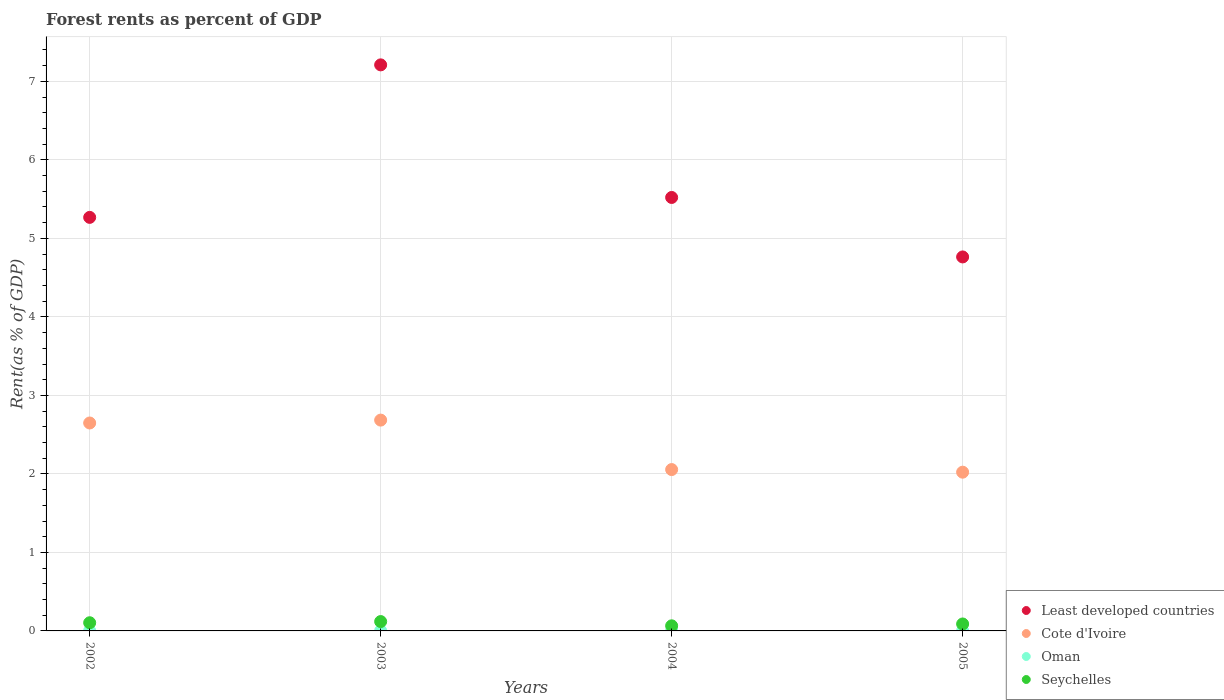What is the forest rent in Oman in 2002?
Make the answer very short. 0. Across all years, what is the maximum forest rent in Least developed countries?
Offer a very short reply. 7.21. Across all years, what is the minimum forest rent in Cote d'Ivoire?
Offer a terse response. 2.02. In which year was the forest rent in Oman maximum?
Ensure brevity in your answer.  2004. What is the total forest rent in Least developed countries in the graph?
Keep it short and to the point. 22.76. What is the difference between the forest rent in Seychelles in 2002 and that in 2003?
Provide a short and direct response. -0.02. What is the difference between the forest rent in Least developed countries in 2002 and the forest rent in Seychelles in 2005?
Keep it short and to the point. 5.18. What is the average forest rent in Least developed countries per year?
Provide a short and direct response. 5.69. In the year 2004, what is the difference between the forest rent in Seychelles and forest rent in Oman?
Your answer should be very brief. 0.06. In how many years, is the forest rent in Seychelles greater than 1.2 %?
Your answer should be compact. 0. What is the ratio of the forest rent in Oman in 2002 to that in 2004?
Provide a succinct answer. 0.96. Is the forest rent in Oman in 2003 less than that in 2005?
Make the answer very short. No. Is the difference between the forest rent in Seychelles in 2003 and 2004 greater than the difference between the forest rent in Oman in 2003 and 2004?
Give a very brief answer. Yes. What is the difference between the highest and the second highest forest rent in Cote d'Ivoire?
Your answer should be compact. 0.04. What is the difference between the highest and the lowest forest rent in Least developed countries?
Provide a short and direct response. 2.45. In how many years, is the forest rent in Oman greater than the average forest rent in Oman taken over all years?
Keep it short and to the point. 3. Is the sum of the forest rent in Oman in 2002 and 2005 greater than the maximum forest rent in Least developed countries across all years?
Your answer should be very brief. No. Does the forest rent in Least developed countries monotonically increase over the years?
Provide a short and direct response. No. Is the forest rent in Least developed countries strictly greater than the forest rent in Cote d'Ivoire over the years?
Your response must be concise. Yes. How many dotlines are there?
Provide a short and direct response. 4. What is the difference between two consecutive major ticks on the Y-axis?
Offer a terse response. 1. Does the graph contain grids?
Offer a very short reply. Yes. Where does the legend appear in the graph?
Offer a terse response. Bottom right. How many legend labels are there?
Your answer should be very brief. 4. How are the legend labels stacked?
Provide a short and direct response. Vertical. What is the title of the graph?
Provide a short and direct response. Forest rents as percent of GDP. What is the label or title of the Y-axis?
Your answer should be very brief. Rent(as % of GDP). What is the Rent(as % of GDP) of Least developed countries in 2002?
Your answer should be compact. 5.27. What is the Rent(as % of GDP) of Cote d'Ivoire in 2002?
Your answer should be compact. 2.65. What is the Rent(as % of GDP) in Oman in 2002?
Provide a short and direct response. 0. What is the Rent(as % of GDP) of Seychelles in 2002?
Ensure brevity in your answer.  0.1. What is the Rent(as % of GDP) in Least developed countries in 2003?
Give a very brief answer. 7.21. What is the Rent(as % of GDP) of Cote d'Ivoire in 2003?
Offer a very short reply. 2.69. What is the Rent(as % of GDP) of Oman in 2003?
Keep it short and to the point. 0. What is the Rent(as % of GDP) in Seychelles in 2003?
Ensure brevity in your answer.  0.12. What is the Rent(as % of GDP) in Least developed countries in 2004?
Make the answer very short. 5.52. What is the Rent(as % of GDP) in Cote d'Ivoire in 2004?
Provide a short and direct response. 2.06. What is the Rent(as % of GDP) in Oman in 2004?
Make the answer very short. 0. What is the Rent(as % of GDP) in Seychelles in 2004?
Provide a short and direct response. 0.06. What is the Rent(as % of GDP) in Least developed countries in 2005?
Ensure brevity in your answer.  4.76. What is the Rent(as % of GDP) in Cote d'Ivoire in 2005?
Offer a very short reply. 2.02. What is the Rent(as % of GDP) in Oman in 2005?
Make the answer very short. 0. What is the Rent(as % of GDP) in Seychelles in 2005?
Offer a terse response. 0.09. Across all years, what is the maximum Rent(as % of GDP) of Least developed countries?
Your response must be concise. 7.21. Across all years, what is the maximum Rent(as % of GDP) of Cote d'Ivoire?
Provide a succinct answer. 2.69. Across all years, what is the maximum Rent(as % of GDP) in Oman?
Your response must be concise. 0. Across all years, what is the maximum Rent(as % of GDP) in Seychelles?
Your answer should be compact. 0.12. Across all years, what is the minimum Rent(as % of GDP) of Least developed countries?
Offer a terse response. 4.76. Across all years, what is the minimum Rent(as % of GDP) in Cote d'Ivoire?
Offer a very short reply. 2.02. Across all years, what is the minimum Rent(as % of GDP) of Oman?
Your response must be concise. 0. Across all years, what is the minimum Rent(as % of GDP) in Seychelles?
Give a very brief answer. 0.06. What is the total Rent(as % of GDP) of Least developed countries in the graph?
Give a very brief answer. 22.76. What is the total Rent(as % of GDP) in Cote d'Ivoire in the graph?
Your response must be concise. 9.41. What is the total Rent(as % of GDP) in Oman in the graph?
Your response must be concise. 0.01. What is the total Rent(as % of GDP) of Seychelles in the graph?
Provide a short and direct response. 0.38. What is the difference between the Rent(as % of GDP) of Least developed countries in 2002 and that in 2003?
Make the answer very short. -1.94. What is the difference between the Rent(as % of GDP) of Cote d'Ivoire in 2002 and that in 2003?
Your answer should be very brief. -0.04. What is the difference between the Rent(as % of GDP) of Oman in 2002 and that in 2003?
Give a very brief answer. -0. What is the difference between the Rent(as % of GDP) in Seychelles in 2002 and that in 2003?
Make the answer very short. -0.02. What is the difference between the Rent(as % of GDP) in Least developed countries in 2002 and that in 2004?
Offer a terse response. -0.25. What is the difference between the Rent(as % of GDP) of Cote d'Ivoire in 2002 and that in 2004?
Your answer should be compact. 0.59. What is the difference between the Rent(as % of GDP) of Oman in 2002 and that in 2004?
Offer a terse response. -0. What is the difference between the Rent(as % of GDP) of Seychelles in 2002 and that in 2004?
Keep it short and to the point. 0.04. What is the difference between the Rent(as % of GDP) of Least developed countries in 2002 and that in 2005?
Give a very brief answer. 0.5. What is the difference between the Rent(as % of GDP) of Cote d'Ivoire in 2002 and that in 2005?
Ensure brevity in your answer.  0.63. What is the difference between the Rent(as % of GDP) in Oman in 2002 and that in 2005?
Your answer should be compact. 0. What is the difference between the Rent(as % of GDP) in Seychelles in 2002 and that in 2005?
Ensure brevity in your answer.  0.02. What is the difference between the Rent(as % of GDP) of Least developed countries in 2003 and that in 2004?
Keep it short and to the point. 1.69. What is the difference between the Rent(as % of GDP) of Cote d'Ivoire in 2003 and that in 2004?
Offer a very short reply. 0.63. What is the difference between the Rent(as % of GDP) of Seychelles in 2003 and that in 2004?
Offer a terse response. 0.05. What is the difference between the Rent(as % of GDP) of Least developed countries in 2003 and that in 2005?
Provide a succinct answer. 2.45. What is the difference between the Rent(as % of GDP) of Cote d'Ivoire in 2003 and that in 2005?
Provide a succinct answer. 0.66. What is the difference between the Rent(as % of GDP) of Oman in 2003 and that in 2005?
Make the answer very short. 0. What is the difference between the Rent(as % of GDP) in Seychelles in 2003 and that in 2005?
Offer a terse response. 0.03. What is the difference between the Rent(as % of GDP) of Least developed countries in 2004 and that in 2005?
Your response must be concise. 0.76. What is the difference between the Rent(as % of GDP) in Oman in 2004 and that in 2005?
Your response must be concise. 0. What is the difference between the Rent(as % of GDP) in Seychelles in 2004 and that in 2005?
Ensure brevity in your answer.  -0.02. What is the difference between the Rent(as % of GDP) in Least developed countries in 2002 and the Rent(as % of GDP) in Cote d'Ivoire in 2003?
Give a very brief answer. 2.58. What is the difference between the Rent(as % of GDP) of Least developed countries in 2002 and the Rent(as % of GDP) of Oman in 2003?
Your answer should be very brief. 5.26. What is the difference between the Rent(as % of GDP) of Least developed countries in 2002 and the Rent(as % of GDP) of Seychelles in 2003?
Provide a succinct answer. 5.15. What is the difference between the Rent(as % of GDP) of Cote d'Ivoire in 2002 and the Rent(as % of GDP) of Oman in 2003?
Ensure brevity in your answer.  2.65. What is the difference between the Rent(as % of GDP) of Cote d'Ivoire in 2002 and the Rent(as % of GDP) of Seychelles in 2003?
Provide a succinct answer. 2.53. What is the difference between the Rent(as % of GDP) in Oman in 2002 and the Rent(as % of GDP) in Seychelles in 2003?
Your response must be concise. -0.12. What is the difference between the Rent(as % of GDP) of Least developed countries in 2002 and the Rent(as % of GDP) of Cote d'Ivoire in 2004?
Ensure brevity in your answer.  3.21. What is the difference between the Rent(as % of GDP) in Least developed countries in 2002 and the Rent(as % of GDP) in Oman in 2004?
Offer a very short reply. 5.26. What is the difference between the Rent(as % of GDP) of Least developed countries in 2002 and the Rent(as % of GDP) of Seychelles in 2004?
Your response must be concise. 5.2. What is the difference between the Rent(as % of GDP) in Cote d'Ivoire in 2002 and the Rent(as % of GDP) in Oman in 2004?
Offer a terse response. 2.65. What is the difference between the Rent(as % of GDP) of Cote d'Ivoire in 2002 and the Rent(as % of GDP) of Seychelles in 2004?
Offer a very short reply. 2.58. What is the difference between the Rent(as % of GDP) of Oman in 2002 and the Rent(as % of GDP) of Seychelles in 2004?
Give a very brief answer. -0.06. What is the difference between the Rent(as % of GDP) in Least developed countries in 2002 and the Rent(as % of GDP) in Cote d'Ivoire in 2005?
Provide a succinct answer. 3.25. What is the difference between the Rent(as % of GDP) of Least developed countries in 2002 and the Rent(as % of GDP) of Oman in 2005?
Your response must be concise. 5.27. What is the difference between the Rent(as % of GDP) in Least developed countries in 2002 and the Rent(as % of GDP) in Seychelles in 2005?
Your answer should be compact. 5.18. What is the difference between the Rent(as % of GDP) of Cote d'Ivoire in 2002 and the Rent(as % of GDP) of Oman in 2005?
Your answer should be very brief. 2.65. What is the difference between the Rent(as % of GDP) in Cote d'Ivoire in 2002 and the Rent(as % of GDP) in Seychelles in 2005?
Keep it short and to the point. 2.56. What is the difference between the Rent(as % of GDP) of Oman in 2002 and the Rent(as % of GDP) of Seychelles in 2005?
Your response must be concise. -0.09. What is the difference between the Rent(as % of GDP) in Least developed countries in 2003 and the Rent(as % of GDP) in Cote d'Ivoire in 2004?
Make the answer very short. 5.16. What is the difference between the Rent(as % of GDP) in Least developed countries in 2003 and the Rent(as % of GDP) in Oman in 2004?
Make the answer very short. 7.21. What is the difference between the Rent(as % of GDP) in Least developed countries in 2003 and the Rent(as % of GDP) in Seychelles in 2004?
Keep it short and to the point. 7.15. What is the difference between the Rent(as % of GDP) of Cote d'Ivoire in 2003 and the Rent(as % of GDP) of Oman in 2004?
Ensure brevity in your answer.  2.68. What is the difference between the Rent(as % of GDP) in Cote d'Ivoire in 2003 and the Rent(as % of GDP) in Seychelles in 2004?
Your answer should be very brief. 2.62. What is the difference between the Rent(as % of GDP) of Oman in 2003 and the Rent(as % of GDP) of Seychelles in 2004?
Ensure brevity in your answer.  -0.06. What is the difference between the Rent(as % of GDP) of Least developed countries in 2003 and the Rent(as % of GDP) of Cote d'Ivoire in 2005?
Your answer should be very brief. 5.19. What is the difference between the Rent(as % of GDP) of Least developed countries in 2003 and the Rent(as % of GDP) of Oman in 2005?
Your response must be concise. 7.21. What is the difference between the Rent(as % of GDP) of Least developed countries in 2003 and the Rent(as % of GDP) of Seychelles in 2005?
Give a very brief answer. 7.12. What is the difference between the Rent(as % of GDP) in Cote d'Ivoire in 2003 and the Rent(as % of GDP) in Oman in 2005?
Your response must be concise. 2.68. What is the difference between the Rent(as % of GDP) of Cote d'Ivoire in 2003 and the Rent(as % of GDP) of Seychelles in 2005?
Offer a terse response. 2.6. What is the difference between the Rent(as % of GDP) of Oman in 2003 and the Rent(as % of GDP) of Seychelles in 2005?
Make the answer very short. -0.09. What is the difference between the Rent(as % of GDP) in Least developed countries in 2004 and the Rent(as % of GDP) in Cote d'Ivoire in 2005?
Your response must be concise. 3.5. What is the difference between the Rent(as % of GDP) of Least developed countries in 2004 and the Rent(as % of GDP) of Oman in 2005?
Your answer should be compact. 5.52. What is the difference between the Rent(as % of GDP) in Least developed countries in 2004 and the Rent(as % of GDP) in Seychelles in 2005?
Your response must be concise. 5.43. What is the difference between the Rent(as % of GDP) in Cote d'Ivoire in 2004 and the Rent(as % of GDP) in Oman in 2005?
Give a very brief answer. 2.05. What is the difference between the Rent(as % of GDP) in Cote d'Ivoire in 2004 and the Rent(as % of GDP) in Seychelles in 2005?
Your response must be concise. 1.97. What is the difference between the Rent(as % of GDP) of Oman in 2004 and the Rent(as % of GDP) of Seychelles in 2005?
Offer a terse response. -0.09. What is the average Rent(as % of GDP) in Least developed countries per year?
Offer a terse response. 5.69. What is the average Rent(as % of GDP) of Cote d'Ivoire per year?
Give a very brief answer. 2.35. What is the average Rent(as % of GDP) of Oman per year?
Ensure brevity in your answer.  0. What is the average Rent(as % of GDP) in Seychelles per year?
Make the answer very short. 0.09. In the year 2002, what is the difference between the Rent(as % of GDP) of Least developed countries and Rent(as % of GDP) of Cote d'Ivoire?
Provide a short and direct response. 2.62. In the year 2002, what is the difference between the Rent(as % of GDP) in Least developed countries and Rent(as % of GDP) in Oman?
Keep it short and to the point. 5.26. In the year 2002, what is the difference between the Rent(as % of GDP) in Least developed countries and Rent(as % of GDP) in Seychelles?
Offer a very short reply. 5.16. In the year 2002, what is the difference between the Rent(as % of GDP) in Cote d'Ivoire and Rent(as % of GDP) in Oman?
Ensure brevity in your answer.  2.65. In the year 2002, what is the difference between the Rent(as % of GDP) of Cote d'Ivoire and Rent(as % of GDP) of Seychelles?
Provide a short and direct response. 2.54. In the year 2002, what is the difference between the Rent(as % of GDP) in Oman and Rent(as % of GDP) in Seychelles?
Your answer should be very brief. -0.1. In the year 2003, what is the difference between the Rent(as % of GDP) of Least developed countries and Rent(as % of GDP) of Cote d'Ivoire?
Provide a succinct answer. 4.53. In the year 2003, what is the difference between the Rent(as % of GDP) in Least developed countries and Rent(as % of GDP) in Oman?
Give a very brief answer. 7.21. In the year 2003, what is the difference between the Rent(as % of GDP) of Least developed countries and Rent(as % of GDP) of Seychelles?
Provide a succinct answer. 7.09. In the year 2003, what is the difference between the Rent(as % of GDP) of Cote d'Ivoire and Rent(as % of GDP) of Oman?
Provide a short and direct response. 2.68. In the year 2003, what is the difference between the Rent(as % of GDP) in Cote d'Ivoire and Rent(as % of GDP) in Seychelles?
Provide a succinct answer. 2.57. In the year 2003, what is the difference between the Rent(as % of GDP) in Oman and Rent(as % of GDP) in Seychelles?
Keep it short and to the point. -0.12. In the year 2004, what is the difference between the Rent(as % of GDP) of Least developed countries and Rent(as % of GDP) of Cote d'Ivoire?
Make the answer very short. 3.47. In the year 2004, what is the difference between the Rent(as % of GDP) in Least developed countries and Rent(as % of GDP) in Oman?
Your answer should be very brief. 5.52. In the year 2004, what is the difference between the Rent(as % of GDP) in Least developed countries and Rent(as % of GDP) in Seychelles?
Your response must be concise. 5.46. In the year 2004, what is the difference between the Rent(as % of GDP) in Cote d'Ivoire and Rent(as % of GDP) in Oman?
Offer a terse response. 2.05. In the year 2004, what is the difference between the Rent(as % of GDP) of Cote d'Ivoire and Rent(as % of GDP) of Seychelles?
Offer a terse response. 1.99. In the year 2004, what is the difference between the Rent(as % of GDP) of Oman and Rent(as % of GDP) of Seychelles?
Your answer should be compact. -0.06. In the year 2005, what is the difference between the Rent(as % of GDP) of Least developed countries and Rent(as % of GDP) of Cote d'Ivoire?
Make the answer very short. 2.74. In the year 2005, what is the difference between the Rent(as % of GDP) in Least developed countries and Rent(as % of GDP) in Oman?
Give a very brief answer. 4.76. In the year 2005, what is the difference between the Rent(as % of GDP) of Least developed countries and Rent(as % of GDP) of Seychelles?
Offer a very short reply. 4.68. In the year 2005, what is the difference between the Rent(as % of GDP) in Cote d'Ivoire and Rent(as % of GDP) in Oman?
Your response must be concise. 2.02. In the year 2005, what is the difference between the Rent(as % of GDP) of Cote d'Ivoire and Rent(as % of GDP) of Seychelles?
Offer a terse response. 1.93. In the year 2005, what is the difference between the Rent(as % of GDP) of Oman and Rent(as % of GDP) of Seychelles?
Keep it short and to the point. -0.09. What is the ratio of the Rent(as % of GDP) in Least developed countries in 2002 to that in 2003?
Offer a terse response. 0.73. What is the ratio of the Rent(as % of GDP) in Cote d'Ivoire in 2002 to that in 2003?
Keep it short and to the point. 0.99. What is the ratio of the Rent(as % of GDP) of Oman in 2002 to that in 2003?
Provide a short and direct response. 0.97. What is the ratio of the Rent(as % of GDP) in Seychelles in 2002 to that in 2003?
Provide a succinct answer. 0.87. What is the ratio of the Rent(as % of GDP) in Least developed countries in 2002 to that in 2004?
Your answer should be compact. 0.95. What is the ratio of the Rent(as % of GDP) in Cote d'Ivoire in 2002 to that in 2004?
Offer a terse response. 1.29. What is the ratio of the Rent(as % of GDP) in Oman in 2002 to that in 2004?
Make the answer very short. 0.96. What is the ratio of the Rent(as % of GDP) of Seychelles in 2002 to that in 2004?
Give a very brief answer. 1.6. What is the ratio of the Rent(as % of GDP) of Least developed countries in 2002 to that in 2005?
Keep it short and to the point. 1.11. What is the ratio of the Rent(as % of GDP) of Cote d'Ivoire in 2002 to that in 2005?
Offer a very short reply. 1.31. What is the ratio of the Rent(as % of GDP) of Oman in 2002 to that in 2005?
Make the answer very short. 1.17. What is the ratio of the Rent(as % of GDP) of Seychelles in 2002 to that in 2005?
Your response must be concise. 1.18. What is the ratio of the Rent(as % of GDP) of Least developed countries in 2003 to that in 2004?
Provide a short and direct response. 1.31. What is the ratio of the Rent(as % of GDP) of Cote d'Ivoire in 2003 to that in 2004?
Offer a terse response. 1.31. What is the ratio of the Rent(as % of GDP) in Oman in 2003 to that in 2004?
Provide a succinct answer. 0.99. What is the ratio of the Rent(as % of GDP) of Seychelles in 2003 to that in 2004?
Make the answer very short. 1.84. What is the ratio of the Rent(as % of GDP) of Least developed countries in 2003 to that in 2005?
Make the answer very short. 1.51. What is the ratio of the Rent(as % of GDP) in Cote d'Ivoire in 2003 to that in 2005?
Offer a very short reply. 1.33. What is the ratio of the Rent(as % of GDP) in Oman in 2003 to that in 2005?
Your answer should be compact. 1.2. What is the ratio of the Rent(as % of GDP) in Seychelles in 2003 to that in 2005?
Your answer should be very brief. 1.35. What is the ratio of the Rent(as % of GDP) in Least developed countries in 2004 to that in 2005?
Offer a terse response. 1.16. What is the ratio of the Rent(as % of GDP) of Cote d'Ivoire in 2004 to that in 2005?
Your answer should be compact. 1.02. What is the ratio of the Rent(as % of GDP) of Oman in 2004 to that in 2005?
Give a very brief answer. 1.21. What is the ratio of the Rent(as % of GDP) of Seychelles in 2004 to that in 2005?
Make the answer very short. 0.73. What is the difference between the highest and the second highest Rent(as % of GDP) in Least developed countries?
Your response must be concise. 1.69. What is the difference between the highest and the second highest Rent(as % of GDP) of Cote d'Ivoire?
Your response must be concise. 0.04. What is the difference between the highest and the second highest Rent(as % of GDP) of Seychelles?
Your answer should be very brief. 0.02. What is the difference between the highest and the lowest Rent(as % of GDP) in Least developed countries?
Your answer should be very brief. 2.45. What is the difference between the highest and the lowest Rent(as % of GDP) of Cote d'Ivoire?
Provide a succinct answer. 0.66. What is the difference between the highest and the lowest Rent(as % of GDP) of Oman?
Keep it short and to the point. 0. What is the difference between the highest and the lowest Rent(as % of GDP) of Seychelles?
Keep it short and to the point. 0.05. 